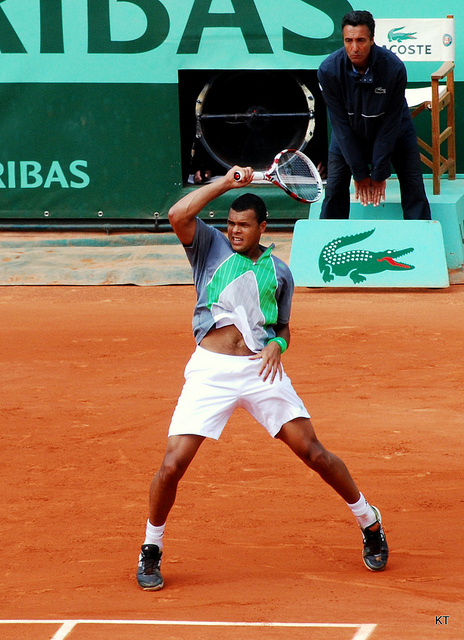What is happening in this scene? The image shows a tennis match in progress. The player on the court is swinging his racket in preparation for a backhand shot. The surface of the court is made of clay, which is typical for many tennis tournaments. The umpire behind him, seated elevated to the side of the court, is watching the play closely. The event is likely a professional one, given the sponsorship signage and the organization of the court. 